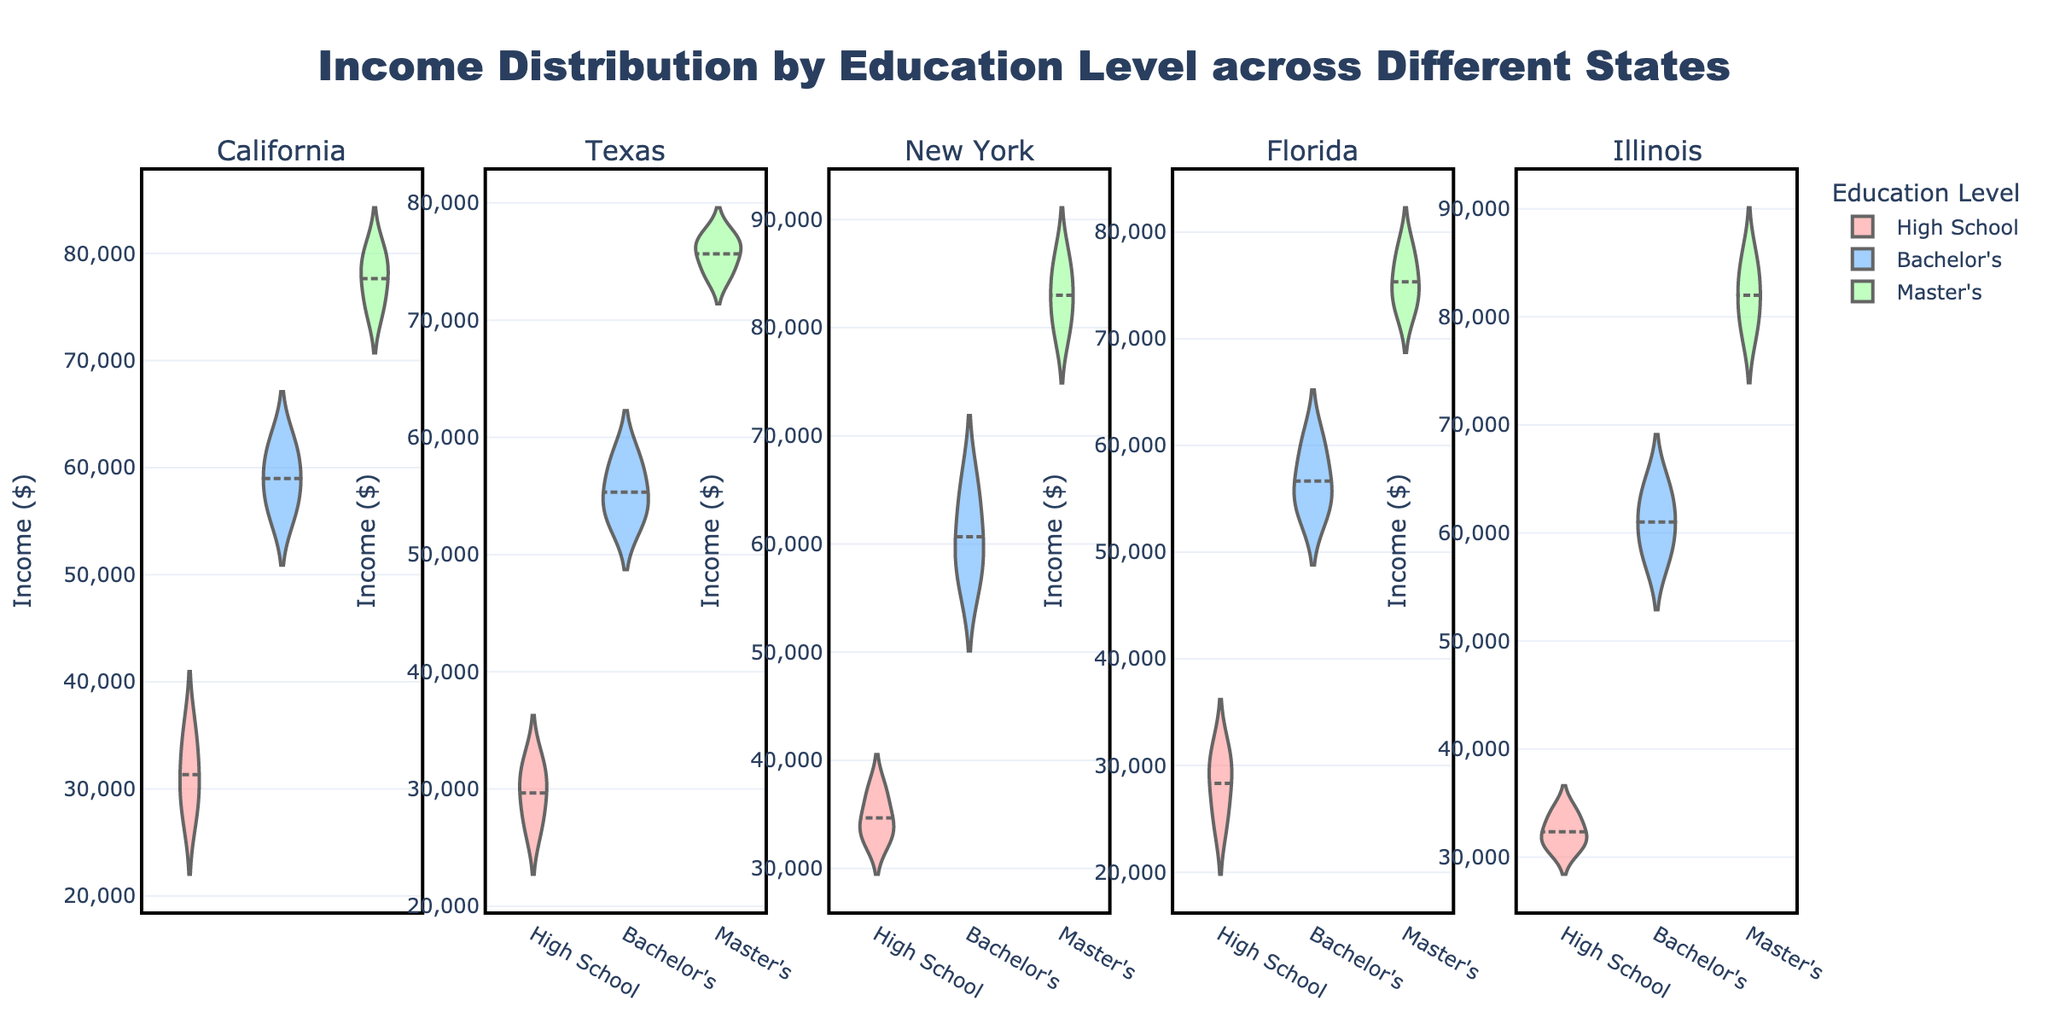What is the title of the figure? The title of a figure is usually clearly mentioned at the top and encapsulates the overall content or focus of the visualization. For this figure, the title is "Income Distribution by Education Level across Different States."
Answer: Income Distribution by Education Level across Different States Which state has the highest median income for people with a Master's degree? To determine the state with the highest median income for Master's degree holders, we should look at the median lines within the violin plots for the Master's category within each state's subplot. New York has the highest median, which can be visually identified on the violin chart.
Answer: New York How does the distribution of income for Bachelor's degree holders in California compare to that in Texas? This comparison involves looking at the shapes of the violin plots for Bachelor's degree holders in California and Texas. In California, the plot shows a wider spread and higher median compared to Texas. Thus, income distribution for Bachelor's degree holders in California is more varied and generally higher.
Answer: California has a wider and higher distribution than Texas In which state is the median income for High School graduates the lowest? To find the lowest median income for High School graduates, examine the median lines in the High School category for all states. Florida's High School graduates have the lowest median income as indicated by the placement of the median line.
Answer: Florida What is the difference in median income between Bachelor's degree holders and Master's degree holders in Illinois? Identify the median lines for both Bachelor's and Master's degree holders in Illinois' subplot. The median income for Bachelor's degree holders is around $61,000, and for Master's degree holders, it is about $82,000. The difference is $82,000 - $61,000 = $21,000.
Answer: $21,000 Which education level shows the least variation in income distribution for New York? Look at the spread of the violin plots in New York's subplot. The tightest or least varied distribution for New York is observed in the Master's degree category.
Answer: Master's Can you rank the states based on the median income for Bachelor's degree holders, from highest to lowest? Examine the median lines in the Bachelor's category for each state's violin subplot. The order from highest to lowest median income for Bachelor's degrees is: New York, Illinois, California, Florida, and Texas.
Answer: New York, Illinois, California, Florida, Texas Do Master's degree holders in Florida have a higher median income compared to those in Texas? Compare the median lines for Master's degree holders in Florida and Texas. The median in Florida is approximately $75,000, while in Texas, it is around $76,000. Thus, Texas has a slightly higher median.
Answer: No, Texas has a higher median What can you infer about the income distributions for California across all education levels? Analyze all three violin plots (High School, Bachelor's, Master's) in California's subplot. The income distributions widen and the median increases as the education level increases. This suggests that higher education correlates with both higher and more varied incomes in California.
Answer: Higher education correlates with higher and more varied incomes Which state shows the widest income distribution range for High School graduates? The widest distribution range for High School graduates can be identified by examining the full span of the violin plot for this category within each state's subplot. New York has the widest range.
Answer: New York 